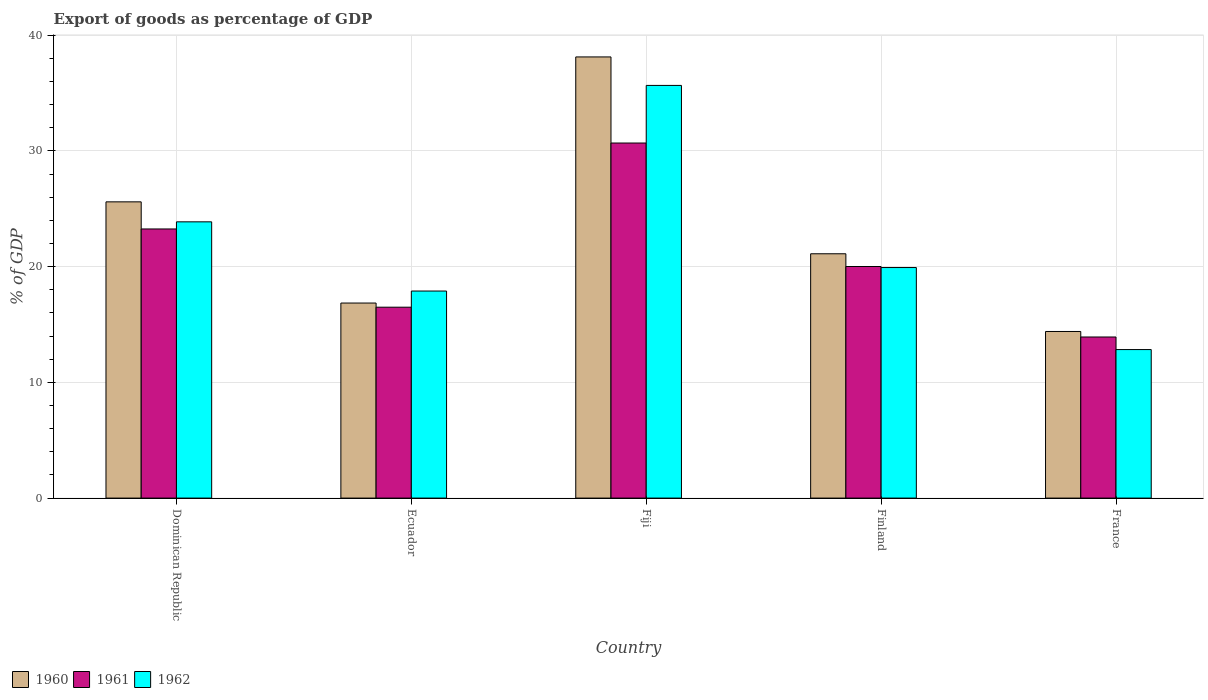Are the number of bars per tick equal to the number of legend labels?
Provide a succinct answer. Yes. How many bars are there on the 4th tick from the left?
Ensure brevity in your answer.  3. What is the label of the 5th group of bars from the left?
Provide a short and direct response. France. What is the export of goods as percentage of GDP in 1960 in Ecuador?
Provide a succinct answer. 16.85. Across all countries, what is the maximum export of goods as percentage of GDP in 1960?
Provide a short and direct response. 38.12. Across all countries, what is the minimum export of goods as percentage of GDP in 1962?
Keep it short and to the point. 12.83. In which country was the export of goods as percentage of GDP in 1960 maximum?
Give a very brief answer. Fiji. What is the total export of goods as percentage of GDP in 1961 in the graph?
Your answer should be compact. 104.35. What is the difference between the export of goods as percentage of GDP in 1962 in Finland and that in France?
Offer a very short reply. 7.09. What is the difference between the export of goods as percentage of GDP in 1962 in Fiji and the export of goods as percentage of GDP in 1961 in Finland?
Your answer should be very brief. 15.65. What is the average export of goods as percentage of GDP in 1961 per country?
Offer a very short reply. 20.87. What is the difference between the export of goods as percentage of GDP of/in 1961 and export of goods as percentage of GDP of/in 1960 in Finland?
Your response must be concise. -1.1. What is the ratio of the export of goods as percentage of GDP in 1960 in Ecuador to that in Fiji?
Keep it short and to the point. 0.44. What is the difference between the highest and the second highest export of goods as percentage of GDP in 1961?
Your answer should be very brief. -10.67. What is the difference between the highest and the lowest export of goods as percentage of GDP in 1961?
Provide a succinct answer. 16.76. In how many countries, is the export of goods as percentage of GDP in 1960 greater than the average export of goods as percentage of GDP in 1960 taken over all countries?
Ensure brevity in your answer.  2. What does the 2nd bar from the left in Ecuador represents?
Make the answer very short. 1961. Is it the case that in every country, the sum of the export of goods as percentage of GDP in 1961 and export of goods as percentage of GDP in 1960 is greater than the export of goods as percentage of GDP in 1962?
Your answer should be very brief. Yes. How many bars are there?
Your answer should be compact. 15. What is the difference between two consecutive major ticks on the Y-axis?
Provide a short and direct response. 10. Are the values on the major ticks of Y-axis written in scientific E-notation?
Provide a succinct answer. No. Does the graph contain grids?
Provide a short and direct response. Yes. Where does the legend appear in the graph?
Keep it short and to the point. Bottom left. What is the title of the graph?
Keep it short and to the point. Export of goods as percentage of GDP. Does "2008" appear as one of the legend labels in the graph?
Your response must be concise. No. What is the label or title of the X-axis?
Your answer should be compact. Country. What is the label or title of the Y-axis?
Your answer should be very brief. % of GDP. What is the % of GDP in 1960 in Dominican Republic?
Your response must be concise. 25.59. What is the % of GDP of 1961 in Dominican Republic?
Offer a terse response. 23.25. What is the % of GDP in 1962 in Dominican Republic?
Ensure brevity in your answer.  23.87. What is the % of GDP of 1960 in Ecuador?
Keep it short and to the point. 16.85. What is the % of GDP of 1961 in Ecuador?
Make the answer very short. 16.49. What is the % of GDP in 1962 in Ecuador?
Your answer should be compact. 17.89. What is the % of GDP of 1960 in Fiji?
Your answer should be very brief. 38.12. What is the % of GDP in 1961 in Fiji?
Provide a succinct answer. 30.68. What is the % of GDP of 1962 in Fiji?
Your answer should be very brief. 35.66. What is the % of GDP in 1960 in Finland?
Offer a terse response. 21.11. What is the % of GDP in 1961 in Finland?
Offer a very short reply. 20.01. What is the % of GDP in 1962 in Finland?
Your answer should be compact. 19.92. What is the % of GDP in 1960 in France?
Provide a short and direct response. 14.4. What is the % of GDP of 1961 in France?
Give a very brief answer. 13.92. What is the % of GDP of 1962 in France?
Ensure brevity in your answer.  12.83. Across all countries, what is the maximum % of GDP in 1960?
Give a very brief answer. 38.12. Across all countries, what is the maximum % of GDP of 1961?
Your response must be concise. 30.68. Across all countries, what is the maximum % of GDP of 1962?
Your answer should be very brief. 35.66. Across all countries, what is the minimum % of GDP of 1960?
Offer a terse response. 14.4. Across all countries, what is the minimum % of GDP of 1961?
Your answer should be very brief. 13.92. Across all countries, what is the minimum % of GDP of 1962?
Ensure brevity in your answer.  12.83. What is the total % of GDP in 1960 in the graph?
Keep it short and to the point. 116.07. What is the total % of GDP in 1961 in the graph?
Provide a succinct answer. 104.35. What is the total % of GDP of 1962 in the graph?
Make the answer very short. 110.17. What is the difference between the % of GDP of 1960 in Dominican Republic and that in Ecuador?
Offer a very short reply. 8.74. What is the difference between the % of GDP in 1961 in Dominican Republic and that in Ecuador?
Offer a terse response. 6.76. What is the difference between the % of GDP in 1962 in Dominican Republic and that in Ecuador?
Offer a terse response. 5.98. What is the difference between the % of GDP in 1960 in Dominican Republic and that in Fiji?
Keep it short and to the point. -12.52. What is the difference between the % of GDP in 1961 in Dominican Republic and that in Fiji?
Your answer should be very brief. -7.42. What is the difference between the % of GDP in 1962 in Dominican Republic and that in Fiji?
Offer a very short reply. -11.79. What is the difference between the % of GDP in 1960 in Dominican Republic and that in Finland?
Give a very brief answer. 4.49. What is the difference between the % of GDP in 1961 in Dominican Republic and that in Finland?
Your answer should be compact. 3.24. What is the difference between the % of GDP in 1962 in Dominican Republic and that in Finland?
Your response must be concise. 3.95. What is the difference between the % of GDP in 1960 in Dominican Republic and that in France?
Keep it short and to the point. 11.2. What is the difference between the % of GDP of 1961 in Dominican Republic and that in France?
Your response must be concise. 9.33. What is the difference between the % of GDP of 1962 in Dominican Republic and that in France?
Offer a very short reply. 11.04. What is the difference between the % of GDP of 1960 in Ecuador and that in Fiji?
Provide a succinct answer. -21.26. What is the difference between the % of GDP of 1961 in Ecuador and that in Fiji?
Ensure brevity in your answer.  -14.18. What is the difference between the % of GDP in 1962 in Ecuador and that in Fiji?
Ensure brevity in your answer.  -17.77. What is the difference between the % of GDP in 1960 in Ecuador and that in Finland?
Offer a terse response. -4.26. What is the difference between the % of GDP of 1961 in Ecuador and that in Finland?
Your answer should be compact. -3.52. What is the difference between the % of GDP of 1962 in Ecuador and that in Finland?
Your response must be concise. -2.03. What is the difference between the % of GDP of 1960 in Ecuador and that in France?
Offer a very short reply. 2.46. What is the difference between the % of GDP in 1961 in Ecuador and that in France?
Offer a terse response. 2.57. What is the difference between the % of GDP of 1962 in Ecuador and that in France?
Keep it short and to the point. 5.06. What is the difference between the % of GDP in 1960 in Fiji and that in Finland?
Your response must be concise. 17.01. What is the difference between the % of GDP of 1961 in Fiji and that in Finland?
Your answer should be very brief. 10.67. What is the difference between the % of GDP in 1962 in Fiji and that in Finland?
Your answer should be compact. 15.74. What is the difference between the % of GDP in 1960 in Fiji and that in France?
Offer a terse response. 23.72. What is the difference between the % of GDP in 1961 in Fiji and that in France?
Your answer should be very brief. 16.76. What is the difference between the % of GDP in 1962 in Fiji and that in France?
Your response must be concise. 22.82. What is the difference between the % of GDP in 1960 in Finland and that in France?
Offer a terse response. 6.71. What is the difference between the % of GDP in 1961 in Finland and that in France?
Provide a succinct answer. 6.09. What is the difference between the % of GDP of 1962 in Finland and that in France?
Your response must be concise. 7.09. What is the difference between the % of GDP in 1960 in Dominican Republic and the % of GDP in 1961 in Ecuador?
Your answer should be very brief. 9.1. What is the difference between the % of GDP of 1960 in Dominican Republic and the % of GDP of 1962 in Ecuador?
Ensure brevity in your answer.  7.71. What is the difference between the % of GDP in 1961 in Dominican Republic and the % of GDP in 1962 in Ecuador?
Your answer should be very brief. 5.36. What is the difference between the % of GDP in 1960 in Dominican Republic and the % of GDP in 1961 in Fiji?
Ensure brevity in your answer.  -5.08. What is the difference between the % of GDP of 1960 in Dominican Republic and the % of GDP of 1962 in Fiji?
Your response must be concise. -10.06. What is the difference between the % of GDP in 1961 in Dominican Republic and the % of GDP in 1962 in Fiji?
Your response must be concise. -12.4. What is the difference between the % of GDP of 1960 in Dominican Republic and the % of GDP of 1961 in Finland?
Give a very brief answer. 5.59. What is the difference between the % of GDP in 1960 in Dominican Republic and the % of GDP in 1962 in Finland?
Provide a short and direct response. 5.67. What is the difference between the % of GDP in 1961 in Dominican Republic and the % of GDP in 1962 in Finland?
Your answer should be very brief. 3.33. What is the difference between the % of GDP in 1960 in Dominican Republic and the % of GDP in 1961 in France?
Ensure brevity in your answer.  11.68. What is the difference between the % of GDP in 1960 in Dominican Republic and the % of GDP in 1962 in France?
Give a very brief answer. 12.76. What is the difference between the % of GDP in 1961 in Dominican Republic and the % of GDP in 1962 in France?
Provide a short and direct response. 10.42. What is the difference between the % of GDP of 1960 in Ecuador and the % of GDP of 1961 in Fiji?
Ensure brevity in your answer.  -13.83. What is the difference between the % of GDP in 1960 in Ecuador and the % of GDP in 1962 in Fiji?
Your response must be concise. -18.8. What is the difference between the % of GDP in 1961 in Ecuador and the % of GDP in 1962 in Fiji?
Your answer should be very brief. -19.16. What is the difference between the % of GDP of 1960 in Ecuador and the % of GDP of 1961 in Finland?
Ensure brevity in your answer.  -3.16. What is the difference between the % of GDP of 1960 in Ecuador and the % of GDP of 1962 in Finland?
Offer a very short reply. -3.07. What is the difference between the % of GDP in 1961 in Ecuador and the % of GDP in 1962 in Finland?
Your answer should be compact. -3.43. What is the difference between the % of GDP in 1960 in Ecuador and the % of GDP in 1961 in France?
Provide a succinct answer. 2.93. What is the difference between the % of GDP of 1960 in Ecuador and the % of GDP of 1962 in France?
Your answer should be compact. 4.02. What is the difference between the % of GDP of 1961 in Ecuador and the % of GDP of 1962 in France?
Your answer should be very brief. 3.66. What is the difference between the % of GDP in 1960 in Fiji and the % of GDP in 1961 in Finland?
Offer a very short reply. 18.11. What is the difference between the % of GDP of 1960 in Fiji and the % of GDP of 1962 in Finland?
Offer a terse response. 18.2. What is the difference between the % of GDP in 1961 in Fiji and the % of GDP in 1962 in Finland?
Keep it short and to the point. 10.76. What is the difference between the % of GDP in 1960 in Fiji and the % of GDP in 1961 in France?
Offer a terse response. 24.2. What is the difference between the % of GDP in 1960 in Fiji and the % of GDP in 1962 in France?
Offer a terse response. 25.28. What is the difference between the % of GDP of 1961 in Fiji and the % of GDP of 1962 in France?
Provide a short and direct response. 17.85. What is the difference between the % of GDP of 1960 in Finland and the % of GDP of 1961 in France?
Make the answer very short. 7.19. What is the difference between the % of GDP of 1960 in Finland and the % of GDP of 1962 in France?
Your answer should be compact. 8.28. What is the difference between the % of GDP in 1961 in Finland and the % of GDP in 1962 in France?
Make the answer very short. 7.18. What is the average % of GDP of 1960 per country?
Make the answer very short. 23.21. What is the average % of GDP of 1961 per country?
Give a very brief answer. 20.87. What is the average % of GDP in 1962 per country?
Provide a succinct answer. 22.03. What is the difference between the % of GDP of 1960 and % of GDP of 1961 in Dominican Republic?
Make the answer very short. 2.34. What is the difference between the % of GDP of 1960 and % of GDP of 1962 in Dominican Republic?
Provide a succinct answer. 1.73. What is the difference between the % of GDP in 1961 and % of GDP in 1962 in Dominican Republic?
Offer a very short reply. -0.62. What is the difference between the % of GDP in 1960 and % of GDP in 1961 in Ecuador?
Offer a terse response. 0.36. What is the difference between the % of GDP in 1960 and % of GDP in 1962 in Ecuador?
Ensure brevity in your answer.  -1.04. What is the difference between the % of GDP in 1961 and % of GDP in 1962 in Ecuador?
Make the answer very short. -1.4. What is the difference between the % of GDP of 1960 and % of GDP of 1961 in Fiji?
Ensure brevity in your answer.  7.44. What is the difference between the % of GDP in 1960 and % of GDP in 1962 in Fiji?
Offer a very short reply. 2.46. What is the difference between the % of GDP of 1961 and % of GDP of 1962 in Fiji?
Your response must be concise. -4.98. What is the difference between the % of GDP in 1960 and % of GDP in 1961 in Finland?
Your response must be concise. 1.1. What is the difference between the % of GDP of 1960 and % of GDP of 1962 in Finland?
Offer a terse response. 1.19. What is the difference between the % of GDP of 1961 and % of GDP of 1962 in Finland?
Ensure brevity in your answer.  0.09. What is the difference between the % of GDP of 1960 and % of GDP of 1961 in France?
Your response must be concise. 0.48. What is the difference between the % of GDP of 1960 and % of GDP of 1962 in France?
Offer a terse response. 1.56. What is the difference between the % of GDP in 1961 and % of GDP in 1962 in France?
Provide a short and direct response. 1.09. What is the ratio of the % of GDP of 1960 in Dominican Republic to that in Ecuador?
Ensure brevity in your answer.  1.52. What is the ratio of the % of GDP in 1961 in Dominican Republic to that in Ecuador?
Keep it short and to the point. 1.41. What is the ratio of the % of GDP of 1962 in Dominican Republic to that in Ecuador?
Ensure brevity in your answer.  1.33. What is the ratio of the % of GDP in 1960 in Dominican Republic to that in Fiji?
Your answer should be compact. 0.67. What is the ratio of the % of GDP in 1961 in Dominican Republic to that in Fiji?
Ensure brevity in your answer.  0.76. What is the ratio of the % of GDP in 1962 in Dominican Republic to that in Fiji?
Provide a succinct answer. 0.67. What is the ratio of the % of GDP in 1960 in Dominican Republic to that in Finland?
Provide a short and direct response. 1.21. What is the ratio of the % of GDP in 1961 in Dominican Republic to that in Finland?
Offer a very short reply. 1.16. What is the ratio of the % of GDP of 1962 in Dominican Republic to that in Finland?
Make the answer very short. 1.2. What is the ratio of the % of GDP of 1960 in Dominican Republic to that in France?
Give a very brief answer. 1.78. What is the ratio of the % of GDP of 1961 in Dominican Republic to that in France?
Make the answer very short. 1.67. What is the ratio of the % of GDP in 1962 in Dominican Republic to that in France?
Give a very brief answer. 1.86. What is the ratio of the % of GDP of 1960 in Ecuador to that in Fiji?
Your answer should be compact. 0.44. What is the ratio of the % of GDP of 1961 in Ecuador to that in Fiji?
Provide a succinct answer. 0.54. What is the ratio of the % of GDP in 1962 in Ecuador to that in Fiji?
Provide a short and direct response. 0.5. What is the ratio of the % of GDP of 1960 in Ecuador to that in Finland?
Provide a short and direct response. 0.8. What is the ratio of the % of GDP in 1961 in Ecuador to that in Finland?
Ensure brevity in your answer.  0.82. What is the ratio of the % of GDP in 1962 in Ecuador to that in Finland?
Provide a short and direct response. 0.9. What is the ratio of the % of GDP of 1960 in Ecuador to that in France?
Your answer should be compact. 1.17. What is the ratio of the % of GDP in 1961 in Ecuador to that in France?
Your answer should be very brief. 1.18. What is the ratio of the % of GDP in 1962 in Ecuador to that in France?
Provide a short and direct response. 1.39. What is the ratio of the % of GDP of 1960 in Fiji to that in Finland?
Your response must be concise. 1.81. What is the ratio of the % of GDP of 1961 in Fiji to that in Finland?
Ensure brevity in your answer.  1.53. What is the ratio of the % of GDP of 1962 in Fiji to that in Finland?
Make the answer very short. 1.79. What is the ratio of the % of GDP of 1960 in Fiji to that in France?
Offer a very short reply. 2.65. What is the ratio of the % of GDP in 1961 in Fiji to that in France?
Keep it short and to the point. 2.2. What is the ratio of the % of GDP of 1962 in Fiji to that in France?
Offer a terse response. 2.78. What is the ratio of the % of GDP in 1960 in Finland to that in France?
Offer a very short reply. 1.47. What is the ratio of the % of GDP in 1961 in Finland to that in France?
Keep it short and to the point. 1.44. What is the ratio of the % of GDP in 1962 in Finland to that in France?
Provide a succinct answer. 1.55. What is the difference between the highest and the second highest % of GDP in 1960?
Your answer should be compact. 12.52. What is the difference between the highest and the second highest % of GDP in 1961?
Offer a very short reply. 7.42. What is the difference between the highest and the second highest % of GDP in 1962?
Your response must be concise. 11.79. What is the difference between the highest and the lowest % of GDP of 1960?
Offer a very short reply. 23.72. What is the difference between the highest and the lowest % of GDP of 1961?
Ensure brevity in your answer.  16.76. What is the difference between the highest and the lowest % of GDP in 1962?
Offer a terse response. 22.82. 